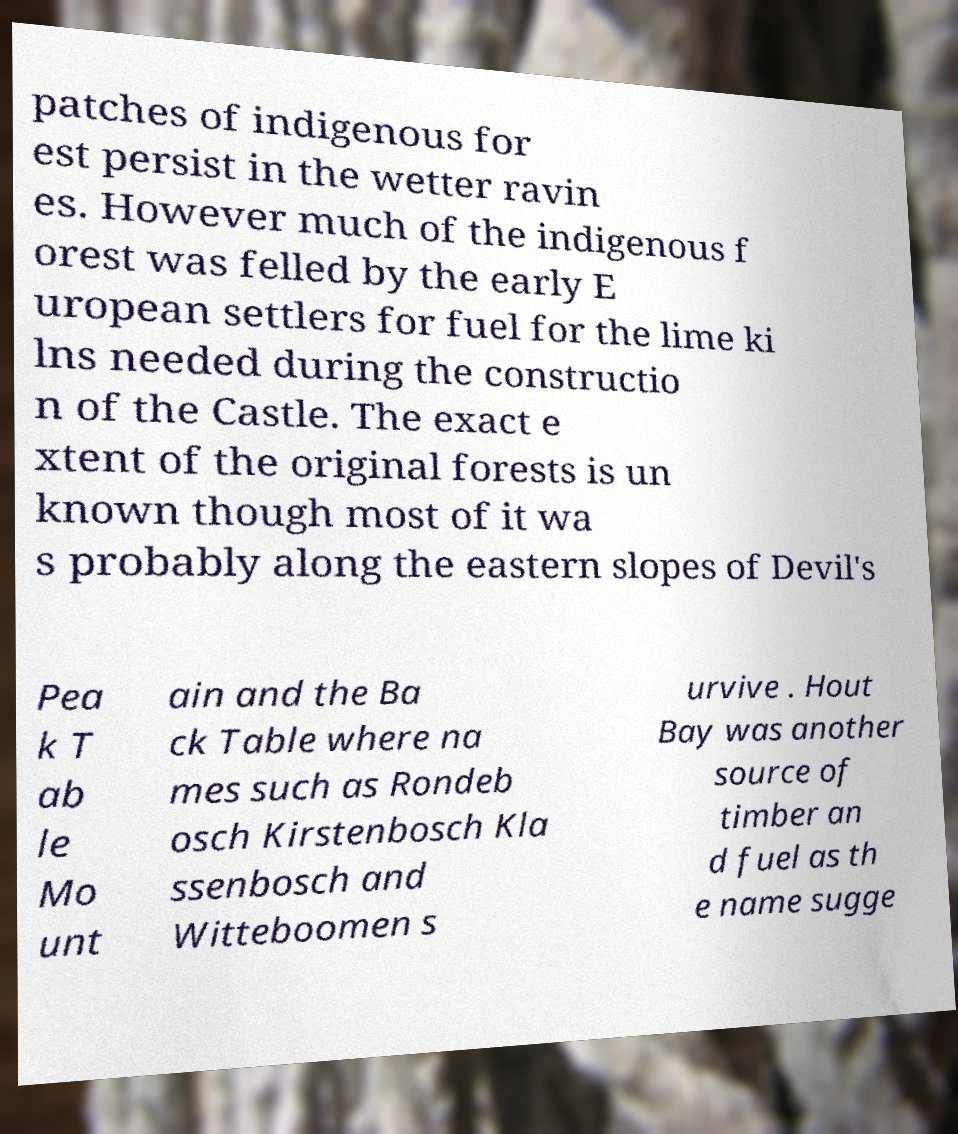Please read and relay the text visible in this image. What does it say? patches of indigenous for est persist in the wetter ravin es. However much of the indigenous f orest was felled by the early E uropean settlers for fuel for the lime ki lns needed during the constructio n of the Castle. The exact e xtent of the original forests is un known though most of it wa s probably along the eastern slopes of Devil's Pea k T ab le Mo unt ain and the Ba ck Table where na mes such as Rondeb osch Kirstenbosch Kla ssenbosch and Witteboomen s urvive . Hout Bay was another source of timber an d fuel as th e name sugge 